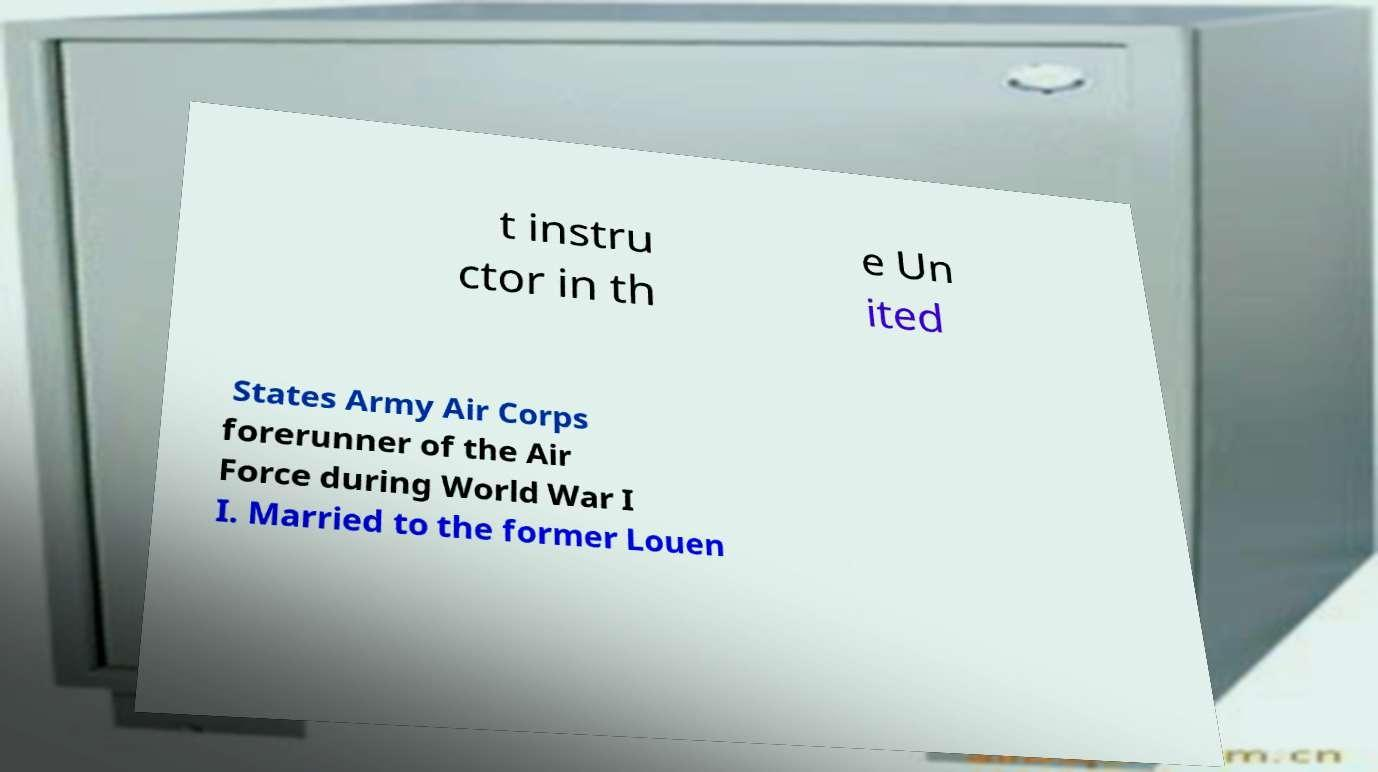Can you accurately transcribe the text from the provided image for me? t instru ctor in th e Un ited States Army Air Corps forerunner of the Air Force during World War I I. Married to the former Louen 